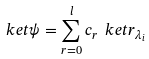<formula> <loc_0><loc_0><loc_500><loc_500>\ k e t { \psi } = \sum _ { r = 0 } ^ { l } c _ { r } \ k e t { r } _ { \lambda _ { i } }</formula> 